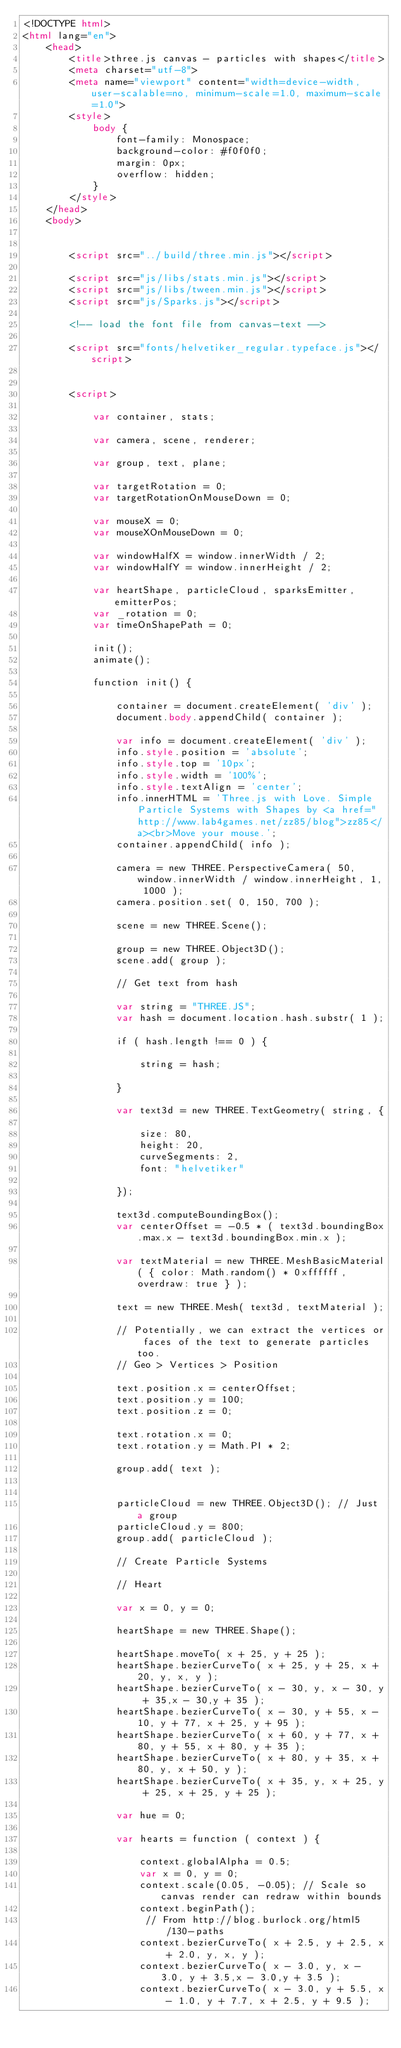<code> <loc_0><loc_0><loc_500><loc_500><_HTML_><!DOCTYPE html>
<html lang="en">
	<head>
		<title>three.js canvas - particles with shapes</title>
		<meta charset="utf-8">
		<meta name="viewport" content="width=device-width, user-scalable=no, minimum-scale=1.0, maximum-scale=1.0">
		<style>
			body {
				font-family: Monospace;
				background-color: #f0f0f0;
				margin: 0px;
				overflow: hidden;
			}
		</style>
	</head>
	<body>


		<script src="../build/three.min.js"></script>

		<script src="js/libs/stats.min.js"></script>
		<script src="js/libs/tween.min.js"></script>
		<script src="js/Sparks.js"></script>

		<!-- load the font file from canvas-text -->

		<script src="fonts/helvetiker_regular.typeface.js"></script>


		<script>

			var container, stats;

			var camera, scene, renderer;

			var group, text, plane;

			var targetRotation = 0;
			var targetRotationOnMouseDown = 0;

			var mouseX = 0;
			var mouseXOnMouseDown = 0;

			var windowHalfX = window.innerWidth / 2;
			var windowHalfY = window.innerHeight / 2;

			var heartShape, particleCloud, sparksEmitter, emitterPos;
			var _rotation = 0;
			var timeOnShapePath = 0;

			init();
			animate();

			function init() {

				container = document.createElement( 'div' );
				document.body.appendChild( container );

				var info = document.createElement( 'div' );
				info.style.position = 'absolute';
				info.style.top = '10px';
				info.style.width = '100%';
				info.style.textAlign = 'center';
				info.innerHTML = 'Three.js with Love. Simple Particle Systems with Shapes by <a href="http://www.lab4games.net/zz85/blog">zz85</a><br>Move your mouse.';
				container.appendChild( info );

				camera = new THREE.PerspectiveCamera( 50, window.innerWidth / window.innerHeight, 1, 1000 );
				camera.position.set( 0, 150, 700 );

				scene = new THREE.Scene();

				group = new THREE.Object3D();
				scene.add( group );

				// Get text from hash

				var string = "THREE.JS";
				var hash = document.location.hash.substr( 1 );

				if ( hash.length !== 0 ) {

					string = hash;

				}

				var text3d = new THREE.TextGeometry( string, {

					size: 80,
					height: 20,
					curveSegments: 2,
					font: "helvetiker"

				});

				text3d.computeBoundingBox();
				var centerOffset = -0.5 * ( text3d.boundingBox.max.x - text3d.boundingBox.min.x );

				var textMaterial = new THREE.MeshBasicMaterial( { color: Math.random() * 0xffffff, overdraw: true } );

				text = new THREE.Mesh( text3d, textMaterial );

				// Potentially, we can extract the vertices or faces of the text to generate particles too.
				// Geo > Vertices > Position

				text.position.x = centerOffset;
				text.position.y = 100;
				text.position.z = 0;

				text.rotation.x = 0;
				text.rotation.y = Math.PI * 2;

				group.add( text );


				particleCloud = new THREE.Object3D(); // Just a group
				particleCloud.y = 800;
				group.add( particleCloud );

				// Create Particle Systems

				// Heart

				var x = 0, y = 0;

				heartShape = new THREE.Shape();

				heartShape.moveTo( x + 25, y + 25 );
				heartShape.bezierCurveTo( x + 25, y + 25, x + 20, y, x, y );
				heartShape.bezierCurveTo( x - 30, y, x - 30, y + 35,x - 30,y + 35 );
				heartShape.bezierCurveTo( x - 30, y + 55, x - 10, y + 77, x + 25, y + 95 );
				heartShape.bezierCurveTo( x + 60, y + 77, x + 80, y + 55, x + 80, y + 35 );
				heartShape.bezierCurveTo( x + 80, y + 35, x + 80, y, x + 50, y );
				heartShape.bezierCurveTo( x + 35, y, x + 25, y + 25, x + 25, y + 25 );

				var hue = 0;

				var hearts = function ( context ) {

					context.globalAlpha = 0.5;
					var x = 0, y = 0;
					context.scale(0.05, -0.05); // Scale so canvas render can redraw within bounds
					context.beginPath();
					 // From http://blog.burlock.org/html5/130-paths
					context.bezierCurveTo( x + 2.5, y + 2.5, x + 2.0, y, x, y );
					context.bezierCurveTo( x - 3.0, y, x - 3.0, y + 3.5,x - 3.0,y + 3.5 );
					context.bezierCurveTo( x - 3.0, y + 5.5, x - 1.0, y + 7.7, x + 2.5, y + 9.5 );</code> 